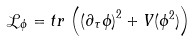Convert formula to latex. <formula><loc_0><loc_0><loc_500><loc_500>\mathcal { L } _ { \phi } = t r \, \left ( \left ( \partial _ { \tau } \phi \right ) ^ { 2 } + V ( \phi ^ { 2 } ) \right )</formula> 